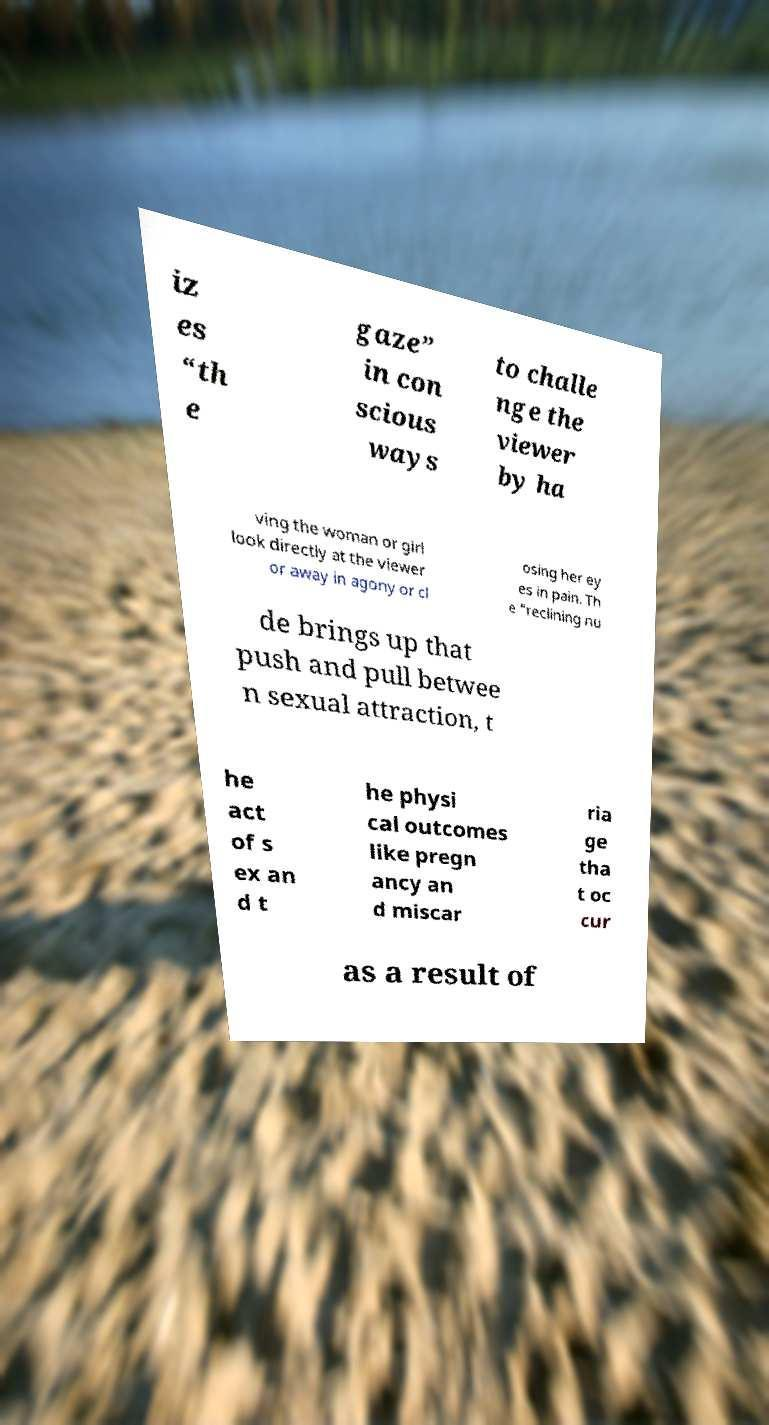Could you assist in decoding the text presented in this image and type it out clearly? iz es “th e gaze” in con scious ways to challe nge the viewer by ha ving the woman or girl look directly at the viewer or away in agony or cl osing her ey es in pain. Th e “reclining nu de brings up that push and pull betwee n sexual attraction, t he act of s ex an d t he physi cal outcomes like pregn ancy an d miscar ria ge tha t oc cur as a result of 